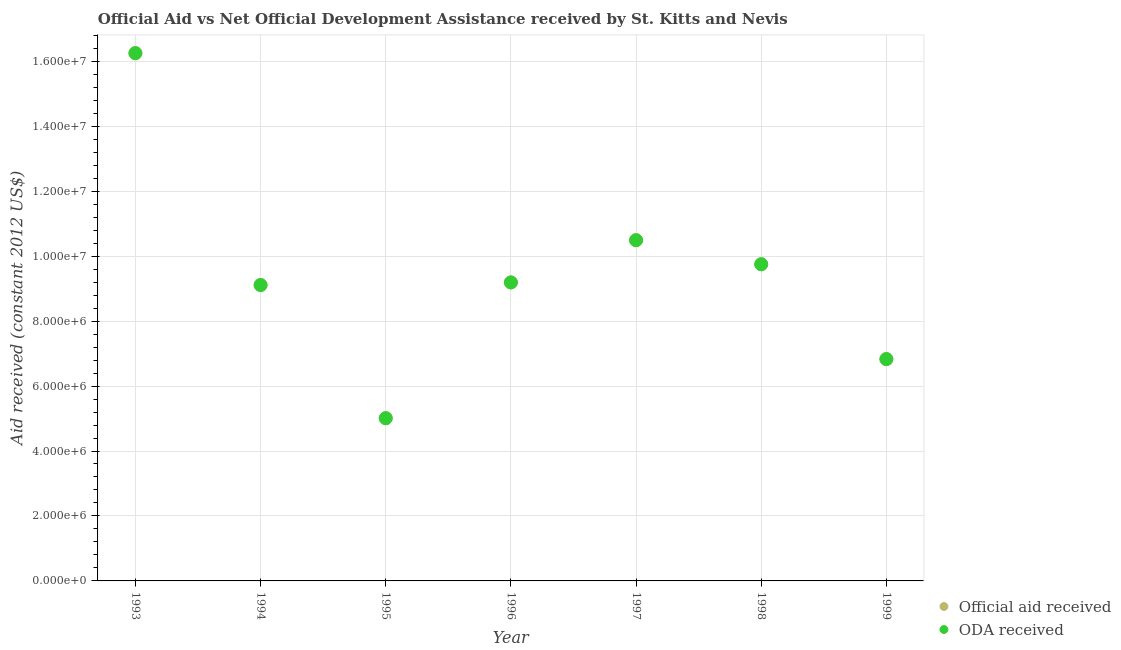How many different coloured dotlines are there?
Your answer should be compact. 2. What is the official aid received in 1999?
Provide a succinct answer. 6.83e+06. Across all years, what is the maximum official aid received?
Your answer should be very brief. 1.62e+07. Across all years, what is the minimum official aid received?
Provide a succinct answer. 5.01e+06. In which year was the official aid received maximum?
Keep it short and to the point. 1993. In which year was the official aid received minimum?
Keep it short and to the point. 1995. What is the total oda received in the graph?
Offer a terse response. 6.66e+07. What is the difference between the oda received in 1993 and that in 1996?
Provide a short and direct response. 7.06e+06. What is the difference between the oda received in 1997 and the official aid received in 1994?
Give a very brief answer. 1.38e+06. What is the average oda received per year?
Your response must be concise. 9.52e+06. What is the ratio of the official aid received in 1995 to that in 1998?
Provide a succinct answer. 0.51. Is the official aid received in 1996 less than that in 1997?
Keep it short and to the point. Yes. What is the difference between the highest and the second highest official aid received?
Offer a terse response. 5.76e+06. What is the difference between the highest and the lowest official aid received?
Provide a short and direct response. 1.12e+07. Does the graph contain any zero values?
Your response must be concise. No. How are the legend labels stacked?
Your answer should be compact. Vertical. What is the title of the graph?
Ensure brevity in your answer.  Official Aid vs Net Official Development Assistance received by St. Kitts and Nevis . Does "Private consumption" appear as one of the legend labels in the graph?
Your answer should be very brief. No. What is the label or title of the Y-axis?
Keep it short and to the point. Aid received (constant 2012 US$). What is the Aid received (constant 2012 US$) in Official aid received in 1993?
Give a very brief answer. 1.62e+07. What is the Aid received (constant 2012 US$) in ODA received in 1993?
Make the answer very short. 1.62e+07. What is the Aid received (constant 2012 US$) in Official aid received in 1994?
Give a very brief answer. 9.11e+06. What is the Aid received (constant 2012 US$) of ODA received in 1994?
Your response must be concise. 9.11e+06. What is the Aid received (constant 2012 US$) in Official aid received in 1995?
Your response must be concise. 5.01e+06. What is the Aid received (constant 2012 US$) of ODA received in 1995?
Ensure brevity in your answer.  5.01e+06. What is the Aid received (constant 2012 US$) in Official aid received in 1996?
Ensure brevity in your answer.  9.19e+06. What is the Aid received (constant 2012 US$) in ODA received in 1996?
Your answer should be very brief. 9.19e+06. What is the Aid received (constant 2012 US$) in Official aid received in 1997?
Offer a terse response. 1.05e+07. What is the Aid received (constant 2012 US$) of ODA received in 1997?
Keep it short and to the point. 1.05e+07. What is the Aid received (constant 2012 US$) in Official aid received in 1998?
Offer a terse response. 9.75e+06. What is the Aid received (constant 2012 US$) in ODA received in 1998?
Your answer should be very brief. 9.75e+06. What is the Aid received (constant 2012 US$) of Official aid received in 1999?
Your answer should be compact. 6.83e+06. What is the Aid received (constant 2012 US$) in ODA received in 1999?
Provide a succinct answer. 6.83e+06. Across all years, what is the maximum Aid received (constant 2012 US$) of Official aid received?
Ensure brevity in your answer.  1.62e+07. Across all years, what is the maximum Aid received (constant 2012 US$) of ODA received?
Make the answer very short. 1.62e+07. Across all years, what is the minimum Aid received (constant 2012 US$) in Official aid received?
Keep it short and to the point. 5.01e+06. Across all years, what is the minimum Aid received (constant 2012 US$) in ODA received?
Your answer should be very brief. 5.01e+06. What is the total Aid received (constant 2012 US$) in Official aid received in the graph?
Offer a very short reply. 6.66e+07. What is the total Aid received (constant 2012 US$) of ODA received in the graph?
Your response must be concise. 6.66e+07. What is the difference between the Aid received (constant 2012 US$) in Official aid received in 1993 and that in 1994?
Give a very brief answer. 7.14e+06. What is the difference between the Aid received (constant 2012 US$) in ODA received in 1993 and that in 1994?
Provide a succinct answer. 7.14e+06. What is the difference between the Aid received (constant 2012 US$) of Official aid received in 1993 and that in 1995?
Provide a short and direct response. 1.12e+07. What is the difference between the Aid received (constant 2012 US$) in ODA received in 1993 and that in 1995?
Offer a terse response. 1.12e+07. What is the difference between the Aid received (constant 2012 US$) of Official aid received in 1993 and that in 1996?
Keep it short and to the point. 7.06e+06. What is the difference between the Aid received (constant 2012 US$) in ODA received in 1993 and that in 1996?
Make the answer very short. 7.06e+06. What is the difference between the Aid received (constant 2012 US$) of Official aid received in 1993 and that in 1997?
Provide a short and direct response. 5.76e+06. What is the difference between the Aid received (constant 2012 US$) in ODA received in 1993 and that in 1997?
Provide a short and direct response. 5.76e+06. What is the difference between the Aid received (constant 2012 US$) of Official aid received in 1993 and that in 1998?
Your response must be concise. 6.50e+06. What is the difference between the Aid received (constant 2012 US$) in ODA received in 1993 and that in 1998?
Your answer should be very brief. 6.50e+06. What is the difference between the Aid received (constant 2012 US$) in Official aid received in 1993 and that in 1999?
Offer a terse response. 9.42e+06. What is the difference between the Aid received (constant 2012 US$) of ODA received in 1993 and that in 1999?
Offer a terse response. 9.42e+06. What is the difference between the Aid received (constant 2012 US$) in Official aid received in 1994 and that in 1995?
Your answer should be compact. 4.10e+06. What is the difference between the Aid received (constant 2012 US$) in ODA received in 1994 and that in 1995?
Keep it short and to the point. 4.10e+06. What is the difference between the Aid received (constant 2012 US$) in Official aid received in 1994 and that in 1996?
Offer a very short reply. -8.00e+04. What is the difference between the Aid received (constant 2012 US$) in Official aid received in 1994 and that in 1997?
Your response must be concise. -1.38e+06. What is the difference between the Aid received (constant 2012 US$) in ODA received in 1994 and that in 1997?
Offer a terse response. -1.38e+06. What is the difference between the Aid received (constant 2012 US$) in Official aid received in 1994 and that in 1998?
Your answer should be very brief. -6.40e+05. What is the difference between the Aid received (constant 2012 US$) in ODA received in 1994 and that in 1998?
Your answer should be compact. -6.40e+05. What is the difference between the Aid received (constant 2012 US$) of Official aid received in 1994 and that in 1999?
Provide a short and direct response. 2.28e+06. What is the difference between the Aid received (constant 2012 US$) in ODA received in 1994 and that in 1999?
Your response must be concise. 2.28e+06. What is the difference between the Aid received (constant 2012 US$) in Official aid received in 1995 and that in 1996?
Provide a succinct answer. -4.18e+06. What is the difference between the Aid received (constant 2012 US$) in ODA received in 1995 and that in 1996?
Keep it short and to the point. -4.18e+06. What is the difference between the Aid received (constant 2012 US$) in Official aid received in 1995 and that in 1997?
Ensure brevity in your answer.  -5.48e+06. What is the difference between the Aid received (constant 2012 US$) in ODA received in 1995 and that in 1997?
Your answer should be very brief. -5.48e+06. What is the difference between the Aid received (constant 2012 US$) of Official aid received in 1995 and that in 1998?
Your answer should be compact. -4.74e+06. What is the difference between the Aid received (constant 2012 US$) in ODA received in 1995 and that in 1998?
Provide a succinct answer. -4.74e+06. What is the difference between the Aid received (constant 2012 US$) in Official aid received in 1995 and that in 1999?
Keep it short and to the point. -1.82e+06. What is the difference between the Aid received (constant 2012 US$) of ODA received in 1995 and that in 1999?
Your answer should be very brief. -1.82e+06. What is the difference between the Aid received (constant 2012 US$) in Official aid received in 1996 and that in 1997?
Offer a terse response. -1.30e+06. What is the difference between the Aid received (constant 2012 US$) in ODA received in 1996 and that in 1997?
Give a very brief answer. -1.30e+06. What is the difference between the Aid received (constant 2012 US$) of Official aid received in 1996 and that in 1998?
Provide a short and direct response. -5.60e+05. What is the difference between the Aid received (constant 2012 US$) in ODA received in 1996 and that in 1998?
Your answer should be very brief. -5.60e+05. What is the difference between the Aid received (constant 2012 US$) of Official aid received in 1996 and that in 1999?
Provide a succinct answer. 2.36e+06. What is the difference between the Aid received (constant 2012 US$) of ODA received in 1996 and that in 1999?
Give a very brief answer. 2.36e+06. What is the difference between the Aid received (constant 2012 US$) of Official aid received in 1997 and that in 1998?
Keep it short and to the point. 7.40e+05. What is the difference between the Aid received (constant 2012 US$) of ODA received in 1997 and that in 1998?
Your answer should be compact. 7.40e+05. What is the difference between the Aid received (constant 2012 US$) of Official aid received in 1997 and that in 1999?
Make the answer very short. 3.66e+06. What is the difference between the Aid received (constant 2012 US$) in ODA received in 1997 and that in 1999?
Ensure brevity in your answer.  3.66e+06. What is the difference between the Aid received (constant 2012 US$) in Official aid received in 1998 and that in 1999?
Ensure brevity in your answer.  2.92e+06. What is the difference between the Aid received (constant 2012 US$) in ODA received in 1998 and that in 1999?
Keep it short and to the point. 2.92e+06. What is the difference between the Aid received (constant 2012 US$) in Official aid received in 1993 and the Aid received (constant 2012 US$) in ODA received in 1994?
Keep it short and to the point. 7.14e+06. What is the difference between the Aid received (constant 2012 US$) of Official aid received in 1993 and the Aid received (constant 2012 US$) of ODA received in 1995?
Your answer should be very brief. 1.12e+07. What is the difference between the Aid received (constant 2012 US$) in Official aid received in 1993 and the Aid received (constant 2012 US$) in ODA received in 1996?
Ensure brevity in your answer.  7.06e+06. What is the difference between the Aid received (constant 2012 US$) in Official aid received in 1993 and the Aid received (constant 2012 US$) in ODA received in 1997?
Your response must be concise. 5.76e+06. What is the difference between the Aid received (constant 2012 US$) of Official aid received in 1993 and the Aid received (constant 2012 US$) of ODA received in 1998?
Give a very brief answer. 6.50e+06. What is the difference between the Aid received (constant 2012 US$) in Official aid received in 1993 and the Aid received (constant 2012 US$) in ODA received in 1999?
Your response must be concise. 9.42e+06. What is the difference between the Aid received (constant 2012 US$) of Official aid received in 1994 and the Aid received (constant 2012 US$) of ODA received in 1995?
Keep it short and to the point. 4.10e+06. What is the difference between the Aid received (constant 2012 US$) of Official aid received in 1994 and the Aid received (constant 2012 US$) of ODA received in 1997?
Keep it short and to the point. -1.38e+06. What is the difference between the Aid received (constant 2012 US$) in Official aid received in 1994 and the Aid received (constant 2012 US$) in ODA received in 1998?
Your response must be concise. -6.40e+05. What is the difference between the Aid received (constant 2012 US$) in Official aid received in 1994 and the Aid received (constant 2012 US$) in ODA received in 1999?
Ensure brevity in your answer.  2.28e+06. What is the difference between the Aid received (constant 2012 US$) in Official aid received in 1995 and the Aid received (constant 2012 US$) in ODA received in 1996?
Offer a very short reply. -4.18e+06. What is the difference between the Aid received (constant 2012 US$) of Official aid received in 1995 and the Aid received (constant 2012 US$) of ODA received in 1997?
Keep it short and to the point. -5.48e+06. What is the difference between the Aid received (constant 2012 US$) in Official aid received in 1995 and the Aid received (constant 2012 US$) in ODA received in 1998?
Your answer should be very brief. -4.74e+06. What is the difference between the Aid received (constant 2012 US$) in Official aid received in 1995 and the Aid received (constant 2012 US$) in ODA received in 1999?
Offer a very short reply. -1.82e+06. What is the difference between the Aid received (constant 2012 US$) in Official aid received in 1996 and the Aid received (constant 2012 US$) in ODA received in 1997?
Offer a very short reply. -1.30e+06. What is the difference between the Aid received (constant 2012 US$) in Official aid received in 1996 and the Aid received (constant 2012 US$) in ODA received in 1998?
Offer a terse response. -5.60e+05. What is the difference between the Aid received (constant 2012 US$) of Official aid received in 1996 and the Aid received (constant 2012 US$) of ODA received in 1999?
Ensure brevity in your answer.  2.36e+06. What is the difference between the Aid received (constant 2012 US$) in Official aid received in 1997 and the Aid received (constant 2012 US$) in ODA received in 1998?
Your response must be concise. 7.40e+05. What is the difference between the Aid received (constant 2012 US$) in Official aid received in 1997 and the Aid received (constant 2012 US$) in ODA received in 1999?
Make the answer very short. 3.66e+06. What is the difference between the Aid received (constant 2012 US$) in Official aid received in 1998 and the Aid received (constant 2012 US$) in ODA received in 1999?
Keep it short and to the point. 2.92e+06. What is the average Aid received (constant 2012 US$) in Official aid received per year?
Provide a succinct answer. 9.52e+06. What is the average Aid received (constant 2012 US$) of ODA received per year?
Keep it short and to the point. 9.52e+06. In the year 1994, what is the difference between the Aid received (constant 2012 US$) in Official aid received and Aid received (constant 2012 US$) in ODA received?
Offer a very short reply. 0. In the year 1995, what is the difference between the Aid received (constant 2012 US$) of Official aid received and Aid received (constant 2012 US$) of ODA received?
Make the answer very short. 0. What is the ratio of the Aid received (constant 2012 US$) in Official aid received in 1993 to that in 1994?
Keep it short and to the point. 1.78. What is the ratio of the Aid received (constant 2012 US$) of ODA received in 1993 to that in 1994?
Your answer should be compact. 1.78. What is the ratio of the Aid received (constant 2012 US$) in Official aid received in 1993 to that in 1995?
Offer a terse response. 3.24. What is the ratio of the Aid received (constant 2012 US$) of ODA received in 1993 to that in 1995?
Provide a succinct answer. 3.24. What is the ratio of the Aid received (constant 2012 US$) of Official aid received in 1993 to that in 1996?
Your response must be concise. 1.77. What is the ratio of the Aid received (constant 2012 US$) in ODA received in 1993 to that in 1996?
Make the answer very short. 1.77. What is the ratio of the Aid received (constant 2012 US$) in Official aid received in 1993 to that in 1997?
Ensure brevity in your answer.  1.55. What is the ratio of the Aid received (constant 2012 US$) in ODA received in 1993 to that in 1997?
Offer a very short reply. 1.55. What is the ratio of the Aid received (constant 2012 US$) of Official aid received in 1993 to that in 1998?
Ensure brevity in your answer.  1.67. What is the ratio of the Aid received (constant 2012 US$) in Official aid received in 1993 to that in 1999?
Offer a terse response. 2.38. What is the ratio of the Aid received (constant 2012 US$) in ODA received in 1993 to that in 1999?
Provide a succinct answer. 2.38. What is the ratio of the Aid received (constant 2012 US$) in Official aid received in 1994 to that in 1995?
Your answer should be compact. 1.82. What is the ratio of the Aid received (constant 2012 US$) of ODA received in 1994 to that in 1995?
Keep it short and to the point. 1.82. What is the ratio of the Aid received (constant 2012 US$) of ODA received in 1994 to that in 1996?
Your answer should be very brief. 0.99. What is the ratio of the Aid received (constant 2012 US$) of Official aid received in 1994 to that in 1997?
Your response must be concise. 0.87. What is the ratio of the Aid received (constant 2012 US$) of ODA received in 1994 to that in 1997?
Your answer should be very brief. 0.87. What is the ratio of the Aid received (constant 2012 US$) in Official aid received in 1994 to that in 1998?
Your answer should be very brief. 0.93. What is the ratio of the Aid received (constant 2012 US$) of ODA received in 1994 to that in 1998?
Your answer should be compact. 0.93. What is the ratio of the Aid received (constant 2012 US$) of Official aid received in 1994 to that in 1999?
Offer a very short reply. 1.33. What is the ratio of the Aid received (constant 2012 US$) of ODA received in 1994 to that in 1999?
Make the answer very short. 1.33. What is the ratio of the Aid received (constant 2012 US$) of Official aid received in 1995 to that in 1996?
Your answer should be very brief. 0.55. What is the ratio of the Aid received (constant 2012 US$) of ODA received in 1995 to that in 1996?
Your answer should be compact. 0.55. What is the ratio of the Aid received (constant 2012 US$) in Official aid received in 1995 to that in 1997?
Keep it short and to the point. 0.48. What is the ratio of the Aid received (constant 2012 US$) in ODA received in 1995 to that in 1997?
Your answer should be compact. 0.48. What is the ratio of the Aid received (constant 2012 US$) of Official aid received in 1995 to that in 1998?
Your response must be concise. 0.51. What is the ratio of the Aid received (constant 2012 US$) of ODA received in 1995 to that in 1998?
Your answer should be very brief. 0.51. What is the ratio of the Aid received (constant 2012 US$) in Official aid received in 1995 to that in 1999?
Your answer should be compact. 0.73. What is the ratio of the Aid received (constant 2012 US$) in ODA received in 1995 to that in 1999?
Your answer should be compact. 0.73. What is the ratio of the Aid received (constant 2012 US$) of Official aid received in 1996 to that in 1997?
Offer a very short reply. 0.88. What is the ratio of the Aid received (constant 2012 US$) in ODA received in 1996 to that in 1997?
Provide a succinct answer. 0.88. What is the ratio of the Aid received (constant 2012 US$) in Official aid received in 1996 to that in 1998?
Make the answer very short. 0.94. What is the ratio of the Aid received (constant 2012 US$) of ODA received in 1996 to that in 1998?
Offer a terse response. 0.94. What is the ratio of the Aid received (constant 2012 US$) of Official aid received in 1996 to that in 1999?
Your answer should be compact. 1.35. What is the ratio of the Aid received (constant 2012 US$) of ODA received in 1996 to that in 1999?
Keep it short and to the point. 1.35. What is the ratio of the Aid received (constant 2012 US$) in Official aid received in 1997 to that in 1998?
Keep it short and to the point. 1.08. What is the ratio of the Aid received (constant 2012 US$) in ODA received in 1997 to that in 1998?
Provide a short and direct response. 1.08. What is the ratio of the Aid received (constant 2012 US$) in Official aid received in 1997 to that in 1999?
Provide a succinct answer. 1.54. What is the ratio of the Aid received (constant 2012 US$) in ODA received in 1997 to that in 1999?
Make the answer very short. 1.54. What is the ratio of the Aid received (constant 2012 US$) in Official aid received in 1998 to that in 1999?
Provide a short and direct response. 1.43. What is the ratio of the Aid received (constant 2012 US$) of ODA received in 1998 to that in 1999?
Keep it short and to the point. 1.43. What is the difference between the highest and the second highest Aid received (constant 2012 US$) in Official aid received?
Ensure brevity in your answer.  5.76e+06. What is the difference between the highest and the second highest Aid received (constant 2012 US$) of ODA received?
Ensure brevity in your answer.  5.76e+06. What is the difference between the highest and the lowest Aid received (constant 2012 US$) in Official aid received?
Ensure brevity in your answer.  1.12e+07. What is the difference between the highest and the lowest Aid received (constant 2012 US$) in ODA received?
Keep it short and to the point. 1.12e+07. 